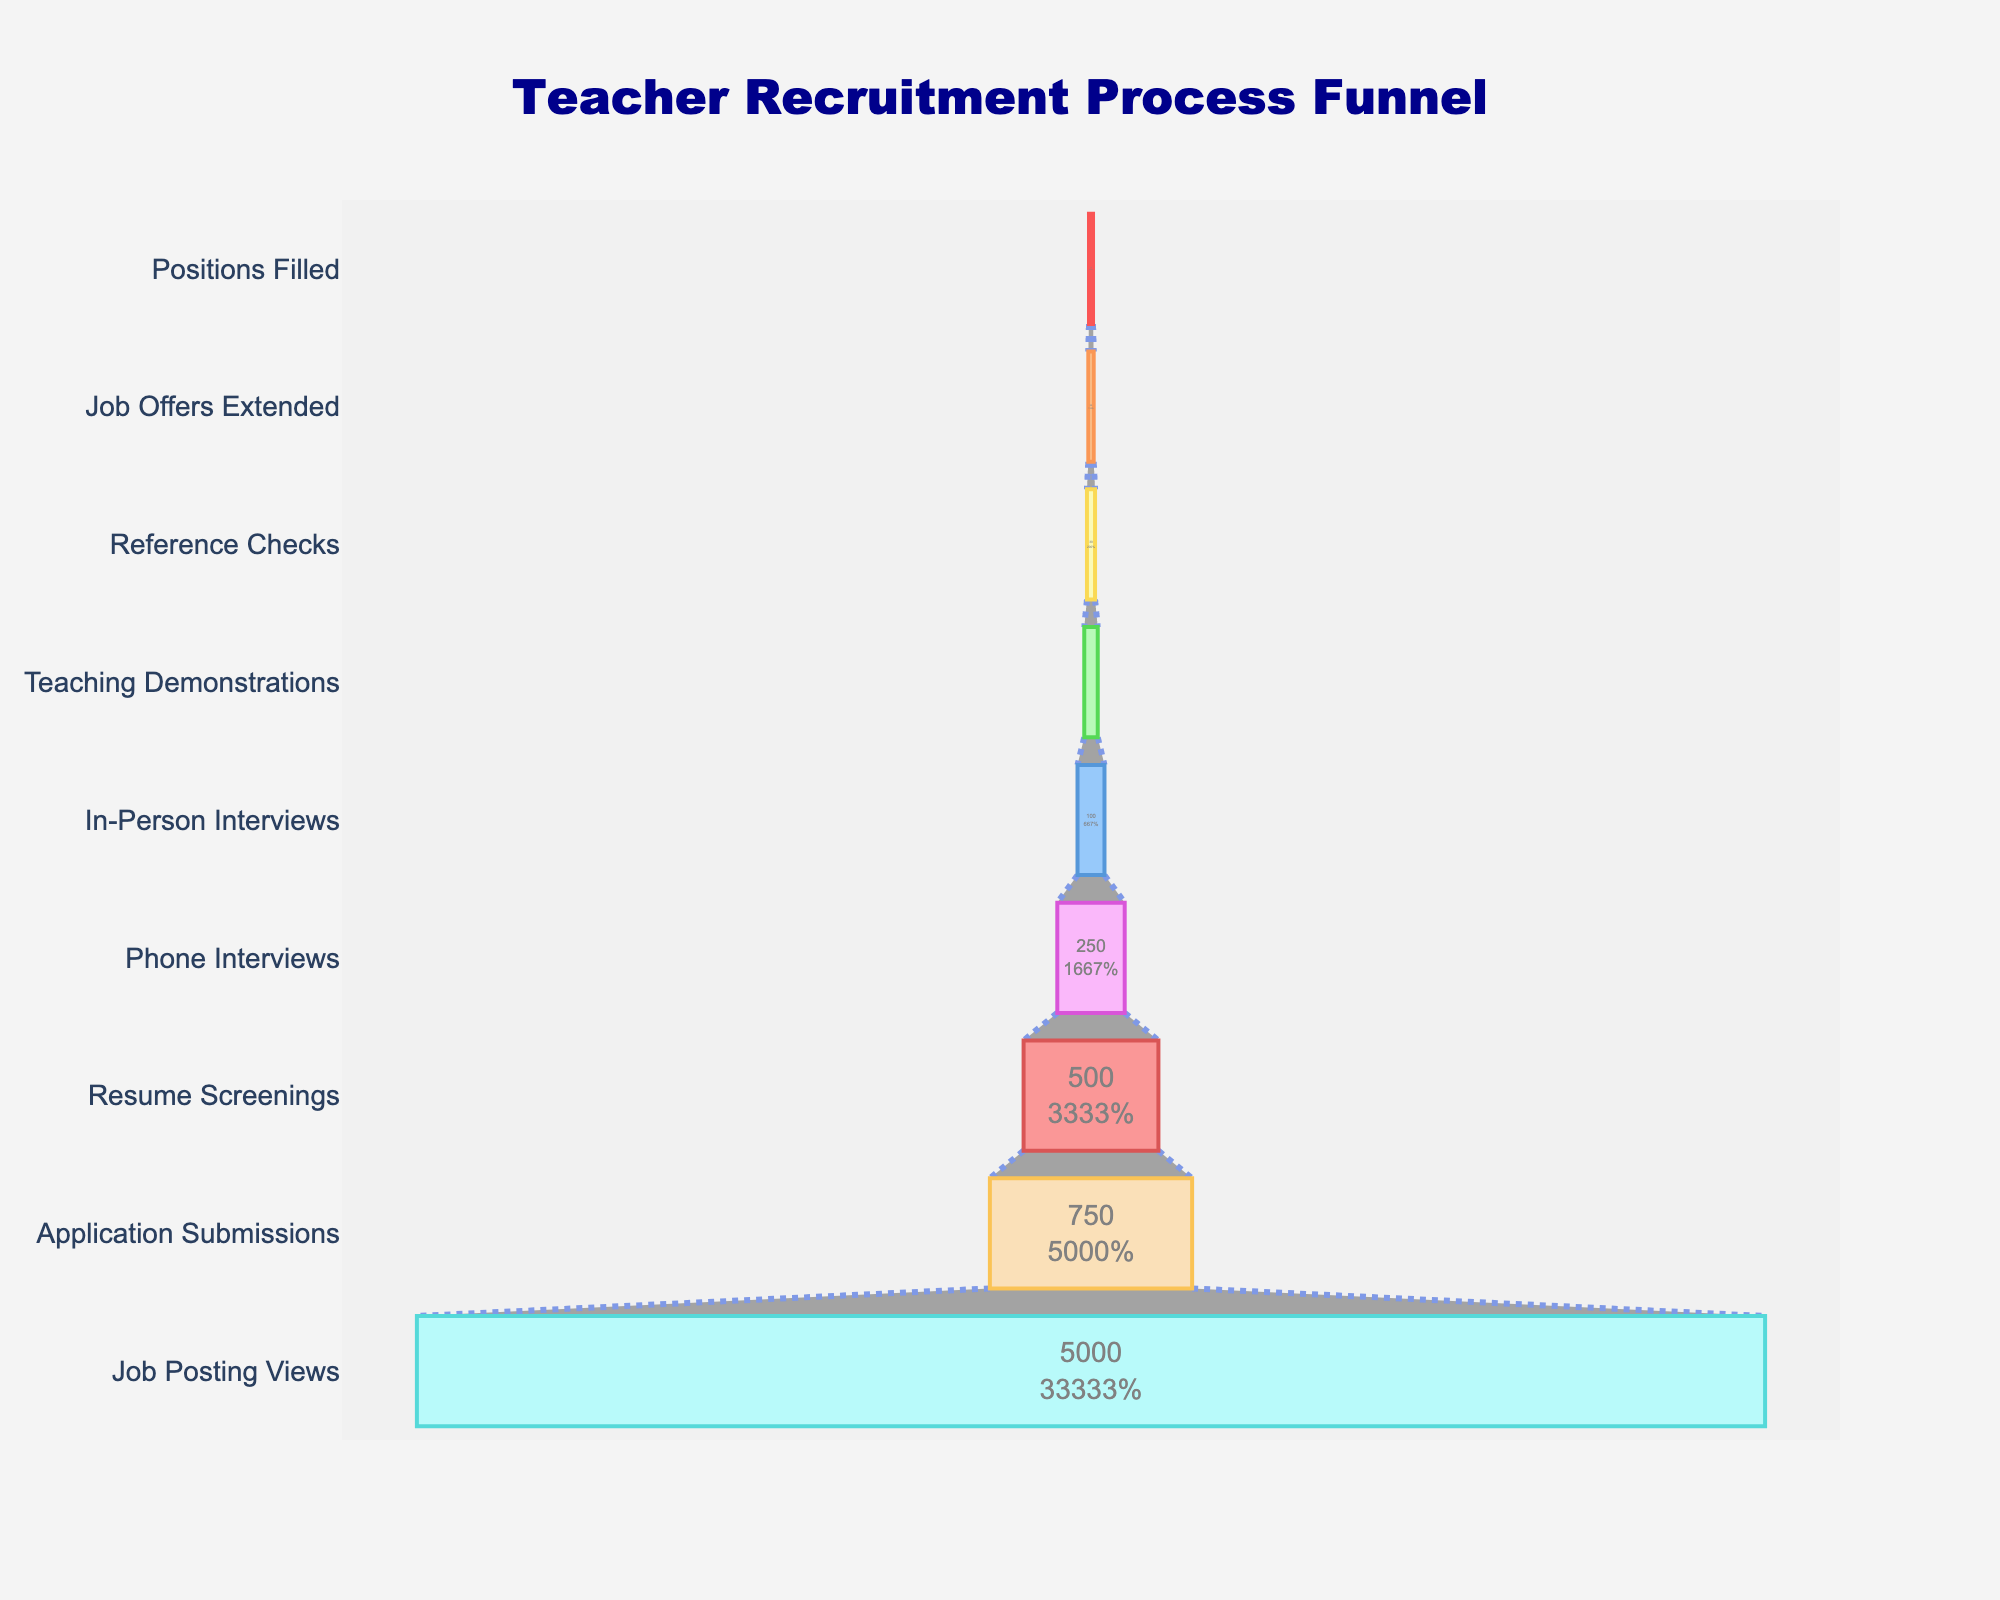What is the title of the funnel chart? The title of the chart is displayed at the top and reads "Teacher Recruitment Process Funnel".
Answer: Teacher Recruitment Process Funnel In which stage were the most candidates involved? The highest number of candidates is at the "Job Posting Views" stage, with 5000 candidates.
Answer: Job Posting Views How many candidates made it to the Teaching Demonstrations stage? The number of candidates is shown next to each stage, and for the "Teaching Demonstrations" stage, it is 50.
Answer: 50 What percentage of candidates moved from Application Submissions to Resume Screenings? Resume Screenings involved 500 candidates out of 750 Application Submissions. The percentage is calculated as (500 / 750) * 100%.
Answer: 66.67% How many more candidates were there at the Phone Interviews stage compared to the Reference Checks stage? The Phone Interviews stage had 250 candidates, and the Reference Checks stage had 30 candidates. The difference is 250 - 30.
Answer: 220 What is the difference in the number of candidates between the Job Offers Extended stage and the Positions Filled stage? The Job Offers Extended stage had 20 candidates, and the Positions Filled stage had 15 candidates. The difference is 20 - 15.
Answer: 5 What is the average number of candidates across all stages? To find the average, sum the number of candidates for all stages and divide by the number of stages: (5000 + 750 + 500 + 250 + 100 + 50 + 30 + 20 + 15) / 9.
Answer: 744.44 Which stage had the smallest number of candidates? The smallest number of candidates is at the "Positions Filled" stage, with 15 candidates.
Answer: Positions Filled By how much did the number of candidates decrease from Job Posting Views to Application Submissions? The number of candidates decreased from 5000 at Job Posting Views to 750 at Application Submissions. The decrease is 5000 - 750
Answer: 4250 At which stage is the drop in the number of candidates the steepest? The steepest drop can be seen from Job Posting Views (5000) to Application Submissions (750).
Answer: Job Posting Views to Application Submissions 